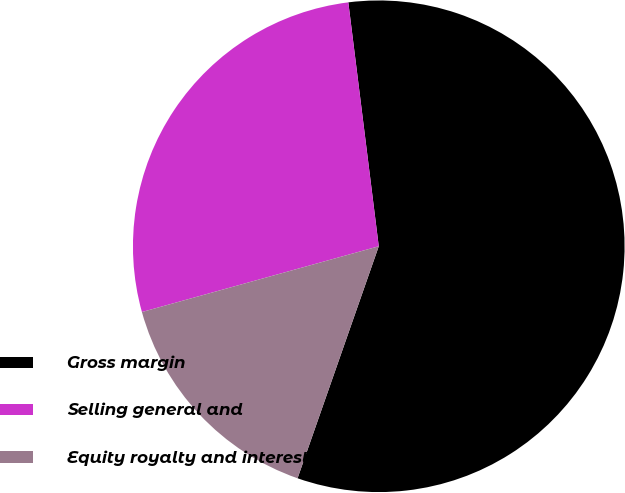Convert chart. <chart><loc_0><loc_0><loc_500><loc_500><pie_chart><fcel>Gross margin<fcel>Selling general and<fcel>Equity royalty and interest<nl><fcel>57.33%<fcel>27.33%<fcel>15.33%<nl></chart> 